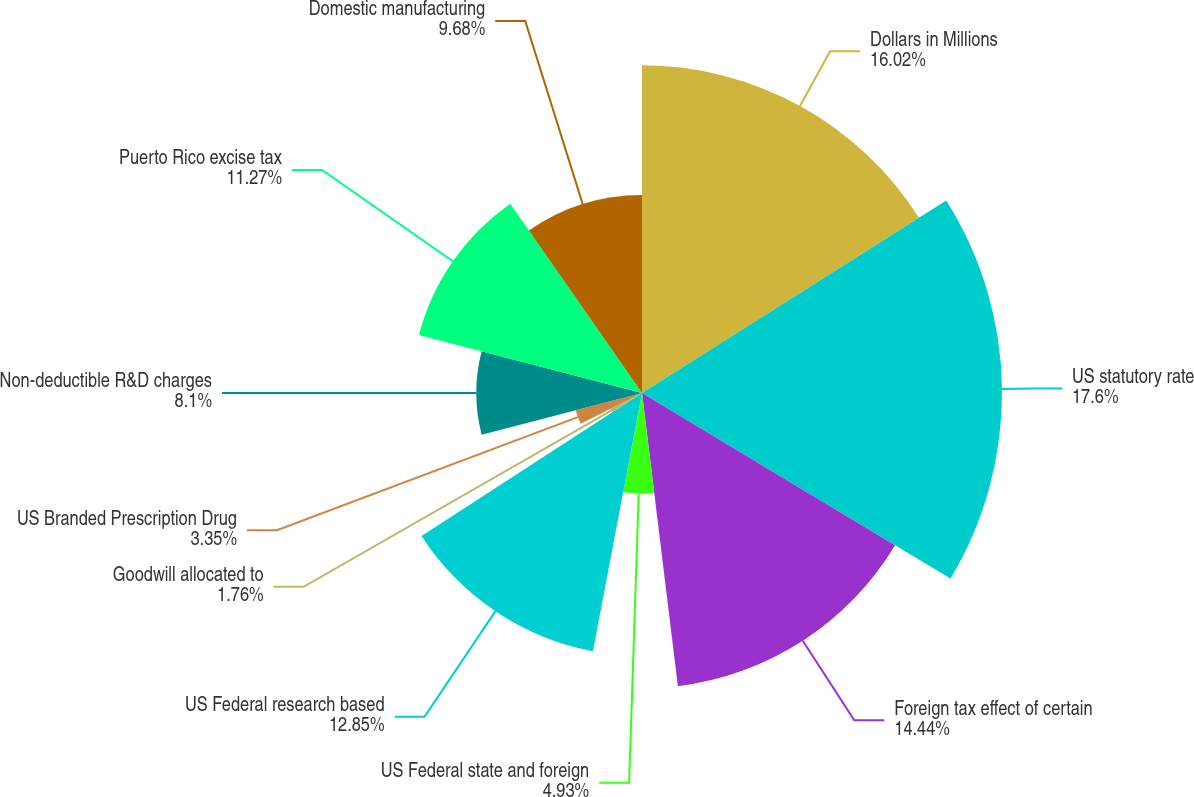Convert chart to OTSL. <chart><loc_0><loc_0><loc_500><loc_500><pie_chart><fcel>Dollars in Millions<fcel>US statutory rate<fcel>Foreign tax effect of certain<fcel>US Federal state and foreign<fcel>US Federal research based<fcel>Goodwill allocated to<fcel>US Branded Prescription Drug<fcel>Non-deductible R&D charges<fcel>Puerto Rico excise tax<fcel>Domestic manufacturing<nl><fcel>16.02%<fcel>17.6%<fcel>14.44%<fcel>4.93%<fcel>12.85%<fcel>1.76%<fcel>3.35%<fcel>8.1%<fcel>11.27%<fcel>9.68%<nl></chart> 